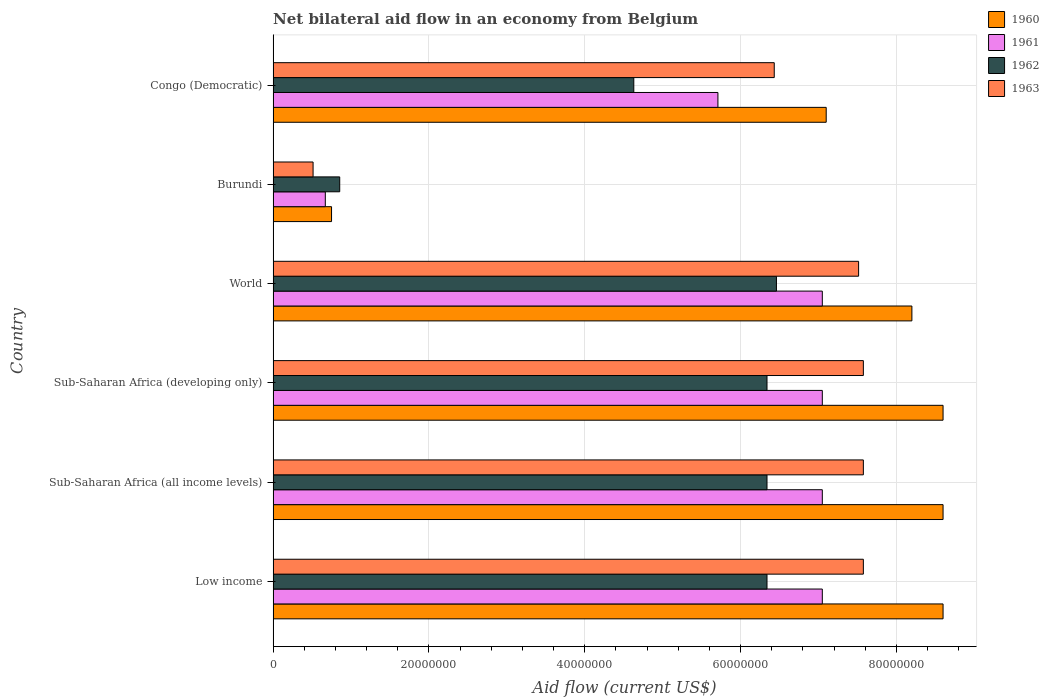Are the number of bars per tick equal to the number of legend labels?
Keep it short and to the point. Yes. What is the label of the 2nd group of bars from the top?
Keep it short and to the point. Burundi. In how many cases, is the number of bars for a given country not equal to the number of legend labels?
Offer a very short reply. 0. What is the net bilateral aid flow in 1963 in Sub-Saharan Africa (all income levels)?
Provide a short and direct response. 7.58e+07. Across all countries, what is the maximum net bilateral aid flow in 1963?
Make the answer very short. 7.58e+07. Across all countries, what is the minimum net bilateral aid flow in 1961?
Ensure brevity in your answer.  6.70e+06. In which country was the net bilateral aid flow in 1962 maximum?
Your answer should be very brief. World. In which country was the net bilateral aid flow in 1961 minimum?
Offer a terse response. Burundi. What is the total net bilateral aid flow in 1960 in the graph?
Offer a very short reply. 4.18e+08. What is the difference between the net bilateral aid flow in 1962 in Burundi and that in Sub-Saharan Africa (developing only)?
Give a very brief answer. -5.48e+07. What is the difference between the net bilateral aid flow in 1960 in Sub-Saharan Africa (all income levels) and the net bilateral aid flow in 1961 in Sub-Saharan Africa (developing only)?
Provide a short and direct response. 1.55e+07. What is the average net bilateral aid flow in 1962 per country?
Your answer should be very brief. 5.16e+07. What is the difference between the net bilateral aid flow in 1960 and net bilateral aid flow in 1961 in World?
Provide a short and direct response. 1.15e+07. In how many countries, is the net bilateral aid flow in 1961 greater than 12000000 US$?
Offer a very short reply. 5. What is the ratio of the net bilateral aid flow in 1961 in Congo (Democratic) to that in Sub-Saharan Africa (all income levels)?
Your response must be concise. 0.81. Is the net bilateral aid flow in 1961 in Low income less than that in Sub-Saharan Africa (developing only)?
Keep it short and to the point. No. What is the difference between the highest and the lowest net bilateral aid flow in 1961?
Provide a succinct answer. 6.38e+07. What does the 2nd bar from the top in World represents?
Make the answer very short. 1962. How many countries are there in the graph?
Offer a terse response. 6. What is the difference between two consecutive major ticks on the X-axis?
Your answer should be compact. 2.00e+07. Are the values on the major ticks of X-axis written in scientific E-notation?
Provide a short and direct response. No. Does the graph contain grids?
Keep it short and to the point. Yes. Where does the legend appear in the graph?
Make the answer very short. Top right. How many legend labels are there?
Provide a short and direct response. 4. What is the title of the graph?
Offer a very short reply. Net bilateral aid flow in an economy from Belgium. Does "1991" appear as one of the legend labels in the graph?
Your answer should be very brief. No. What is the label or title of the X-axis?
Ensure brevity in your answer.  Aid flow (current US$). What is the Aid flow (current US$) of 1960 in Low income?
Your answer should be very brief. 8.60e+07. What is the Aid flow (current US$) in 1961 in Low income?
Your response must be concise. 7.05e+07. What is the Aid flow (current US$) in 1962 in Low income?
Provide a succinct answer. 6.34e+07. What is the Aid flow (current US$) in 1963 in Low income?
Give a very brief answer. 7.58e+07. What is the Aid flow (current US$) of 1960 in Sub-Saharan Africa (all income levels)?
Make the answer very short. 8.60e+07. What is the Aid flow (current US$) in 1961 in Sub-Saharan Africa (all income levels)?
Ensure brevity in your answer.  7.05e+07. What is the Aid flow (current US$) in 1962 in Sub-Saharan Africa (all income levels)?
Offer a terse response. 6.34e+07. What is the Aid flow (current US$) of 1963 in Sub-Saharan Africa (all income levels)?
Keep it short and to the point. 7.58e+07. What is the Aid flow (current US$) of 1960 in Sub-Saharan Africa (developing only)?
Provide a short and direct response. 8.60e+07. What is the Aid flow (current US$) in 1961 in Sub-Saharan Africa (developing only)?
Give a very brief answer. 7.05e+07. What is the Aid flow (current US$) of 1962 in Sub-Saharan Africa (developing only)?
Your answer should be compact. 6.34e+07. What is the Aid flow (current US$) of 1963 in Sub-Saharan Africa (developing only)?
Offer a terse response. 7.58e+07. What is the Aid flow (current US$) in 1960 in World?
Provide a short and direct response. 8.20e+07. What is the Aid flow (current US$) of 1961 in World?
Ensure brevity in your answer.  7.05e+07. What is the Aid flow (current US$) of 1962 in World?
Offer a very short reply. 6.46e+07. What is the Aid flow (current US$) in 1963 in World?
Your response must be concise. 7.52e+07. What is the Aid flow (current US$) in 1960 in Burundi?
Your answer should be compact. 7.50e+06. What is the Aid flow (current US$) in 1961 in Burundi?
Offer a very short reply. 6.70e+06. What is the Aid flow (current US$) of 1962 in Burundi?
Ensure brevity in your answer.  8.55e+06. What is the Aid flow (current US$) in 1963 in Burundi?
Offer a terse response. 5.13e+06. What is the Aid flow (current US$) of 1960 in Congo (Democratic)?
Make the answer very short. 7.10e+07. What is the Aid flow (current US$) of 1961 in Congo (Democratic)?
Keep it short and to the point. 5.71e+07. What is the Aid flow (current US$) of 1962 in Congo (Democratic)?
Your answer should be very brief. 4.63e+07. What is the Aid flow (current US$) in 1963 in Congo (Democratic)?
Your response must be concise. 6.43e+07. Across all countries, what is the maximum Aid flow (current US$) in 1960?
Give a very brief answer. 8.60e+07. Across all countries, what is the maximum Aid flow (current US$) in 1961?
Provide a succinct answer. 7.05e+07. Across all countries, what is the maximum Aid flow (current US$) in 1962?
Ensure brevity in your answer.  6.46e+07. Across all countries, what is the maximum Aid flow (current US$) in 1963?
Your answer should be very brief. 7.58e+07. Across all countries, what is the minimum Aid flow (current US$) in 1960?
Your answer should be compact. 7.50e+06. Across all countries, what is the minimum Aid flow (current US$) in 1961?
Your response must be concise. 6.70e+06. Across all countries, what is the minimum Aid flow (current US$) in 1962?
Provide a succinct answer. 8.55e+06. Across all countries, what is the minimum Aid flow (current US$) of 1963?
Make the answer very short. 5.13e+06. What is the total Aid flow (current US$) in 1960 in the graph?
Provide a succinct answer. 4.18e+08. What is the total Aid flow (current US$) of 1961 in the graph?
Ensure brevity in your answer.  3.46e+08. What is the total Aid flow (current US$) of 1962 in the graph?
Offer a very short reply. 3.10e+08. What is the total Aid flow (current US$) in 1963 in the graph?
Provide a succinct answer. 3.72e+08. What is the difference between the Aid flow (current US$) in 1960 in Low income and that in Sub-Saharan Africa (all income levels)?
Give a very brief answer. 0. What is the difference between the Aid flow (current US$) of 1962 in Low income and that in Sub-Saharan Africa (all income levels)?
Offer a terse response. 0. What is the difference between the Aid flow (current US$) of 1960 in Low income and that in Sub-Saharan Africa (developing only)?
Ensure brevity in your answer.  0. What is the difference between the Aid flow (current US$) in 1961 in Low income and that in Sub-Saharan Africa (developing only)?
Your answer should be very brief. 0. What is the difference between the Aid flow (current US$) of 1962 in Low income and that in Sub-Saharan Africa (developing only)?
Give a very brief answer. 0. What is the difference between the Aid flow (current US$) of 1963 in Low income and that in Sub-Saharan Africa (developing only)?
Give a very brief answer. 0. What is the difference between the Aid flow (current US$) in 1961 in Low income and that in World?
Offer a terse response. 0. What is the difference between the Aid flow (current US$) of 1962 in Low income and that in World?
Provide a succinct answer. -1.21e+06. What is the difference between the Aid flow (current US$) of 1963 in Low income and that in World?
Your answer should be compact. 6.10e+05. What is the difference between the Aid flow (current US$) of 1960 in Low income and that in Burundi?
Keep it short and to the point. 7.85e+07. What is the difference between the Aid flow (current US$) of 1961 in Low income and that in Burundi?
Offer a terse response. 6.38e+07. What is the difference between the Aid flow (current US$) in 1962 in Low income and that in Burundi?
Your answer should be very brief. 5.48e+07. What is the difference between the Aid flow (current US$) in 1963 in Low income and that in Burundi?
Your answer should be compact. 7.06e+07. What is the difference between the Aid flow (current US$) of 1960 in Low income and that in Congo (Democratic)?
Keep it short and to the point. 1.50e+07. What is the difference between the Aid flow (current US$) in 1961 in Low income and that in Congo (Democratic)?
Ensure brevity in your answer.  1.34e+07. What is the difference between the Aid flow (current US$) of 1962 in Low income and that in Congo (Democratic)?
Your answer should be compact. 1.71e+07. What is the difference between the Aid flow (current US$) in 1963 in Low income and that in Congo (Democratic)?
Give a very brief answer. 1.14e+07. What is the difference between the Aid flow (current US$) in 1961 in Sub-Saharan Africa (all income levels) and that in Sub-Saharan Africa (developing only)?
Provide a short and direct response. 0. What is the difference between the Aid flow (current US$) of 1962 in Sub-Saharan Africa (all income levels) and that in Sub-Saharan Africa (developing only)?
Your answer should be very brief. 0. What is the difference between the Aid flow (current US$) in 1963 in Sub-Saharan Africa (all income levels) and that in Sub-Saharan Africa (developing only)?
Offer a terse response. 0. What is the difference between the Aid flow (current US$) of 1960 in Sub-Saharan Africa (all income levels) and that in World?
Make the answer very short. 4.00e+06. What is the difference between the Aid flow (current US$) in 1962 in Sub-Saharan Africa (all income levels) and that in World?
Offer a very short reply. -1.21e+06. What is the difference between the Aid flow (current US$) of 1963 in Sub-Saharan Africa (all income levels) and that in World?
Make the answer very short. 6.10e+05. What is the difference between the Aid flow (current US$) in 1960 in Sub-Saharan Africa (all income levels) and that in Burundi?
Offer a very short reply. 7.85e+07. What is the difference between the Aid flow (current US$) in 1961 in Sub-Saharan Africa (all income levels) and that in Burundi?
Ensure brevity in your answer.  6.38e+07. What is the difference between the Aid flow (current US$) of 1962 in Sub-Saharan Africa (all income levels) and that in Burundi?
Provide a succinct answer. 5.48e+07. What is the difference between the Aid flow (current US$) of 1963 in Sub-Saharan Africa (all income levels) and that in Burundi?
Your answer should be very brief. 7.06e+07. What is the difference between the Aid flow (current US$) of 1960 in Sub-Saharan Africa (all income levels) and that in Congo (Democratic)?
Keep it short and to the point. 1.50e+07. What is the difference between the Aid flow (current US$) of 1961 in Sub-Saharan Africa (all income levels) and that in Congo (Democratic)?
Your answer should be compact. 1.34e+07. What is the difference between the Aid flow (current US$) of 1962 in Sub-Saharan Africa (all income levels) and that in Congo (Democratic)?
Your answer should be compact. 1.71e+07. What is the difference between the Aid flow (current US$) in 1963 in Sub-Saharan Africa (all income levels) and that in Congo (Democratic)?
Give a very brief answer. 1.14e+07. What is the difference between the Aid flow (current US$) of 1960 in Sub-Saharan Africa (developing only) and that in World?
Give a very brief answer. 4.00e+06. What is the difference between the Aid flow (current US$) of 1961 in Sub-Saharan Africa (developing only) and that in World?
Offer a very short reply. 0. What is the difference between the Aid flow (current US$) in 1962 in Sub-Saharan Africa (developing only) and that in World?
Your response must be concise. -1.21e+06. What is the difference between the Aid flow (current US$) in 1963 in Sub-Saharan Africa (developing only) and that in World?
Ensure brevity in your answer.  6.10e+05. What is the difference between the Aid flow (current US$) of 1960 in Sub-Saharan Africa (developing only) and that in Burundi?
Your answer should be compact. 7.85e+07. What is the difference between the Aid flow (current US$) in 1961 in Sub-Saharan Africa (developing only) and that in Burundi?
Offer a very short reply. 6.38e+07. What is the difference between the Aid flow (current US$) in 1962 in Sub-Saharan Africa (developing only) and that in Burundi?
Your response must be concise. 5.48e+07. What is the difference between the Aid flow (current US$) in 1963 in Sub-Saharan Africa (developing only) and that in Burundi?
Ensure brevity in your answer.  7.06e+07. What is the difference between the Aid flow (current US$) of 1960 in Sub-Saharan Africa (developing only) and that in Congo (Democratic)?
Your answer should be very brief. 1.50e+07. What is the difference between the Aid flow (current US$) of 1961 in Sub-Saharan Africa (developing only) and that in Congo (Democratic)?
Provide a short and direct response. 1.34e+07. What is the difference between the Aid flow (current US$) in 1962 in Sub-Saharan Africa (developing only) and that in Congo (Democratic)?
Offer a terse response. 1.71e+07. What is the difference between the Aid flow (current US$) in 1963 in Sub-Saharan Africa (developing only) and that in Congo (Democratic)?
Keep it short and to the point. 1.14e+07. What is the difference between the Aid flow (current US$) in 1960 in World and that in Burundi?
Your answer should be very brief. 7.45e+07. What is the difference between the Aid flow (current US$) in 1961 in World and that in Burundi?
Offer a very short reply. 6.38e+07. What is the difference between the Aid flow (current US$) of 1962 in World and that in Burundi?
Keep it short and to the point. 5.61e+07. What is the difference between the Aid flow (current US$) of 1963 in World and that in Burundi?
Make the answer very short. 7.00e+07. What is the difference between the Aid flow (current US$) in 1960 in World and that in Congo (Democratic)?
Provide a short and direct response. 1.10e+07. What is the difference between the Aid flow (current US$) of 1961 in World and that in Congo (Democratic)?
Keep it short and to the point. 1.34e+07. What is the difference between the Aid flow (current US$) in 1962 in World and that in Congo (Democratic)?
Offer a very short reply. 1.83e+07. What is the difference between the Aid flow (current US$) in 1963 in World and that in Congo (Democratic)?
Your answer should be compact. 1.08e+07. What is the difference between the Aid flow (current US$) of 1960 in Burundi and that in Congo (Democratic)?
Offer a terse response. -6.35e+07. What is the difference between the Aid flow (current US$) in 1961 in Burundi and that in Congo (Democratic)?
Ensure brevity in your answer.  -5.04e+07. What is the difference between the Aid flow (current US$) in 1962 in Burundi and that in Congo (Democratic)?
Make the answer very short. -3.78e+07. What is the difference between the Aid flow (current US$) in 1963 in Burundi and that in Congo (Democratic)?
Your answer should be compact. -5.92e+07. What is the difference between the Aid flow (current US$) in 1960 in Low income and the Aid flow (current US$) in 1961 in Sub-Saharan Africa (all income levels)?
Your response must be concise. 1.55e+07. What is the difference between the Aid flow (current US$) in 1960 in Low income and the Aid flow (current US$) in 1962 in Sub-Saharan Africa (all income levels)?
Your response must be concise. 2.26e+07. What is the difference between the Aid flow (current US$) in 1960 in Low income and the Aid flow (current US$) in 1963 in Sub-Saharan Africa (all income levels)?
Offer a very short reply. 1.02e+07. What is the difference between the Aid flow (current US$) of 1961 in Low income and the Aid flow (current US$) of 1962 in Sub-Saharan Africa (all income levels)?
Provide a short and direct response. 7.10e+06. What is the difference between the Aid flow (current US$) in 1961 in Low income and the Aid flow (current US$) in 1963 in Sub-Saharan Africa (all income levels)?
Ensure brevity in your answer.  -5.27e+06. What is the difference between the Aid flow (current US$) of 1962 in Low income and the Aid flow (current US$) of 1963 in Sub-Saharan Africa (all income levels)?
Your response must be concise. -1.24e+07. What is the difference between the Aid flow (current US$) in 1960 in Low income and the Aid flow (current US$) in 1961 in Sub-Saharan Africa (developing only)?
Offer a terse response. 1.55e+07. What is the difference between the Aid flow (current US$) in 1960 in Low income and the Aid flow (current US$) in 1962 in Sub-Saharan Africa (developing only)?
Keep it short and to the point. 2.26e+07. What is the difference between the Aid flow (current US$) in 1960 in Low income and the Aid flow (current US$) in 1963 in Sub-Saharan Africa (developing only)?
Provide a succinct answer. 1.02e+07. What is the difference between the Aid flow (current US$) of 1961 in Low income and the Aid flow (current US$) of 1962 in Sub-Saharan Africa (developing only)?
Provide a short and direct response. 7.10e+06. What is the difference between the Aid flow (current US$) of 1961 in Low income and the Aid flow (current US$) of 1963 in Sub-Saharan Africa (developing only)?
Keep it short and to the point. -5.27e+06. What is the difference between the Aid flow (current US$) in 1962 in Low income and the Aid flow (current US$) in 1963 in Sub-Saharan Africa (developing only)?
Your answer should be very brief. -1.24e+07. What is the difference between the Aid flow (current US$) of 1960 in Low income and the Aid flow (current US$) of 1961 in World?
Your response must be concise. 1.55e+07. What is the difference between the Aid flow (current US$) of 1960 in Low income and the Aid flow (current US$) of 1962 in World?
Provide a short and direct response. 2.14e+07. What is the difference between the Aid flow (current US$) of 1960 in Low income and the Aid flow (current US$) of 1963 in World?
Offer a terse response. 1.08e+07. What is the difference between the Aid flow (current US$) of 1961 in Low income and the Aid flow (current US$) of 1962 in World?
Provide a succinct answer. 5.89e+06. What is the difference between the Aid flow (current US$) in 1961 in Low income and the Aid flow (current US$) in 1963 in World?
Offer a terse response. -4.66e+06. What is the difference between the Aid flow (current US$) in 1962 in Low income and the Aid flow (current US$) in 1963 in World?
Give a very brief answer. -1.18e+07. What is the difference between the Aid flow (current US$) in 1960 in Low income and the Aid flow (current US$) in 1961 in Burundi?
Your answer should be compact. 7.93e+07. What is the difference between the Aid flow (current US$) in 1960 in Low income and the Aid flow (current US$) in 1962 in Burundi?
Make the answer very short. 7.74e+07. What is the difference between the Aid flow (current US$) of 1960 in Low income and the Aid flow (current US$) of 1963 in Burundi?
Provide a succinct answer. 8.09e+07. What is the difference between the Aid flow (current US$) in 1961 in Low income and the Aid flow (current US$) in 1962 in Burundi?
Your answer should be very brief. 6.20e+07. What is the difference between the Aid flow (current US$) in 1961 in Low income and the Aid flow (current US$) in 1963 in Burundi?
Provide a short and direct response. 6.54e+07. What is the difference between the Aid flow (current US$) in 1962 in Low income and the Aid flow (current US$) in 1963 in Burundi?
Your answer should be very brief. 5.83e+07. What is the difference between the Aid flow (current US$) of 1960 in Low income and the Aid flow (current US$) of 1961 in Congo (Democratic)?
Provide a succinct answer. 2.89e+07. What is the difference between the Aid flow (current US$) in 1960 in Low income and the Aid flow (current US$) in 1962 in Congo (Democratic)?
Provide a succinct answer. 3.97e+07. What is the difference between the Aid flow (current US$) in 1960 in Low income and the Aid flow (current US$) in 1963 in Congo (Democratic)?
Offer a very short reply. 2.17e+07. What is the difference between the Aid flow (current US$) in 1961 in Low income and the Aid flow (current US$) in 1962 in Congo (Democratic)?
Your response must be concise. 2.42e+07. What is the difference between the Aid flow (current US$) in 1961 in Low income and the Aid flow (current US$) in 1963 in Congo (Democratic)?
Your response must be concise. 6.17e+06. What is the difference between the Aid flow (current US$) of 1962 in Low income and the Aid flow (current US$) of 1963 in Congo (Democratic)?
Offer a very short reply. -9.30e+05. What is the difference between the Aid flow (current US$) in 1960 in Sub-Saharan Africa (all income levels) and the Aid flow (current US$) in 1961 in Sub-Saharan Africa (developing only)?
Offer a very short reply. 1.55e+07. What is the difference between the Aid flow (current US$) in 1960 in Sub-Saharan Africa (all income levels) and the Aid flow (current US$) in 1962 in Sub-Saharan Africa (developing only)?
Offer a very short reply. 2.26e+07. What is the difference between the Aid flow (current US$) in 1960 in Sub-Saharan Africa (all income levels) and the Aid flow (current US$) in 1963 in Sub-Saharan Africa (developing only)?
Offer a very short reply. 1.02e+07. What is the difference between the Aid flow (current US$) in 1961 in Sub-Saharan Africa (all income levels) and the Aid flow (current US$) in 1962 in Sub-Saharan Africa (developing only)?
Provide a succinct answer. 7.10e+06. What is the difference between the Aid flow (current US$) in 1961 in Sub-Saharan Africa (all income levels) and the Aid flow (current US$) in 1963 in Sub-Saharan Africa (developing only)?
Keep it short and to the point. -5.27e+06. What is the difference between the Aid flow (current US$) in 1962 in Sub-Saharan Africa (all income levels) and the Aid flow (current US$) in 1963 in Sub-Saharan Africa (developing only)?
Offer a very short reply. -1.24e+07. What is the difference between the Aid flow (current US$) in 1960 in Sub-Saharan Africa (all income levels) and the Aid flow (current US$) in 1961 in World?
Keep it short and to the point. 1.55e+07. What is the difference between the Aid flow (current US$) in 1960 in Sub-Saharan Africa (all income levels) and the Aid flow (current US$) in 1962 in World?
Your answer should be very brief. 2.14e+07. What is the difference between the Aid flow (current US$) in 1960 in Sub-Saharan Africa (all income levels) and the Aid flow (current US$) in 1963 in World?
Keep it short and to the point. 1.08e+07. What is the difference between the Aid flow (current US$) of 1961 in Sub-Saharan Africa (all income levels) and the Aid flow (current US$) of 1962 in World?
Your answer should be compact. 5.89e+06. What is the difference between the Aid flow (current US$) of 1961 in Sub-Saharan Africa (all income levels) and the Aid flow (current US$) of 1963 in World?
Ensure brevity in your answer.  -4.66e+06. What is the difference between the Aid flow (current US$) of 1962 in Sub-Saharan Africa (all income levels) and the Aid flow (current US$) of 1963 in World?
Your response must be concise. -1.18e+07. What is the difference between the Aid flow (current US$) in 1960 in Sub-Saharan Africa (all income levels) and the Aid flow (current US$) in 1961 in Burundi?
Your answer should be very brief. 7.93e+07. What is the difference between the Aid flow (current US$) of 1960 in Sub-Saharan Africa (all income levels) and the Aid flow (current US$) of 1962 in Burundi?
Your answer should be very brief. 7.74e+07. What is the difference between the Aid flow (current US$) in 1960 in Sub-Saharan Africa (all income levels) and the Aid flow (current US$) in 1963 in Burundi?
Offer a very short reply. 8.09e+07. What is the difference between the Aid flow (current US$) in 1961 in Sub-Saharan Africa (all income levels) and the Aid flow (current US$) in 1962 in Burundi?
Give a very brief answer. 6.20e+07. What is the difference between the Aid flow (current US$) of 1961 in Sub-Saharan Africa (all income levels) and the Aid flow (current US$) of 1963 in Burundi?
Your answer should be very brief. 6.54e+07. What is the difference between the Aid flow (current US$) of 1962 in Sub-Saharan Africa (all income levels) and the Aid flow (current US$) of 1963 in Burundi?
Offer a very short reply. 5.83e+07. What is the difference between the Aid flow (current US$) in 1960 in Sub-Saharan Africa (all income levels) and the Aid flow (current US$) in 1961 in Congo (Democratic)?
Make the answer very short. 2.89e+07. What is the difference between the Aid flow (current US$) in 1960 in Sub-Saharan Africa (all income levels) and the Aid flow (current US$) in 1962 in Congo (Democratic)?
Keep it short and to the point. 3.97e+07. What is the difference between the Aid flow (current US$) of 1960 in Sub-Saharan Africa (all income levels) and the Aid flow (current US$) of 1963 in Congo (Democratic)?
Provide a short and direct response. 2.17e+07. What is the difference between the Aid flow (current US$) in 1961 in Sub-Saharan Africa (all income levels) and the Aid flow (current US$) in 1962 in Congo (Democratic)?
Give a very brief answer. 2.42e+07. What is the difference between the Aid flow (current US$) in 1961 in Sub-Saharan Africa (all income levels) and the Aid flow (current US$) in 1963 in Congo (Democratic)?
Ensure brevity in your answer.  6.17e+06. What is the difference between the Aid flow (current US$) of 1962 in Sub-Saharan Africa (all income levels) and the Aid flow (current US$) of 1963 in Congo (Democratic)?
Ensure brevity in your answer.  -9.30e+05. What is the difference between the Aid flow (current US$) of 1960 in Sub-Saharan Africa (developing only) and the Aid flow (current US$) of 1961 in World?
Provide a short and direct response. 1.55e+07. What is the difference between the Aid flow (current US$) in 1960 in Sub-Saharan Africa (developing only) and the Aid flow (current US$) in 1962 in World?
Your answer should be compact. 2.14e+07. What is the difference between the Aid flow (current US$) in 1960 in Sub-Saharan Africa (developing only) and the Aid flow (current US$) in 1963 in World?
Provide a short and direct response. 1.08e+07. What is the difference between the Aid flow (current US$) in 1961 in Sub-Saharan Africa (developing only) and the Aid flow (current US$) in 1962 in World?
Offer a very short reply. 5.89e+06. What is the difference between the Aid flow (current US$) in 1961 in Sub-Saharan Africa (developing only) and the Aid flow (current US$) in 1963 in World?
Your answer should be compact. -4.66e+06. What is the difference between the Aid flow (current US$) in 1962 in Sub-Saharan Africa (developing only) and the Aid flow (current US$) in 1963 in World?
Your response must be concise. -1.18e+07. What is the difference between the Aid flow (current US$) of 1960 in Sub-Saharan Africa (developing only) and the Aid flow (current US$) of 1961 in Burundi?
Provide a succinct answer. 7.93e+07. What is the difference between the Aid flow (current US$) of 1960 in Sub-Saharan Africa (developing only) and the Aid flow (current US$) of 1962 in Burundi?
Offer a very short reply. 7.74e+07. What is the difference between the Aid flow (current US$) of 1960 in Sub-Saharan Africa (developing only) and the Aid flow (current US$) of 1963 in Burundi?
Offer a terse response. 8.09e+07. What is the difference between the Aid flow (current US$) of 1961 in Sub-Saharan Africa (developing only) and the Aid flow (current US$) of 1962 in Burundi?
Your answer should be very brief. 6.20e+07. What is the difference between the Aid flow (current US$) in 1961 in Sub-Saharan Africa (developing only) and the Aid flow (current US$) in 1963 in Burundi?
Give a very brief answer. 6.54e+07. What is the difference between the Aid flow (current US$) of 1962 in Sub-Saharan Africa (developing only) and the Aid flow (current US$) of 1963 in Burundi?
Your answer should be compact. 5.83e+07. What is the difference between the Aid flow (current US$) in 1960 in Sub-Saharan Africa (developing only) and the Aid flow (current US$) in 1961 in Congo (Democratic)?
Provide a succinct answer. 2.89e+07. What is the difference between the Aid flow (current US$) of 1960 in Sub-Saharan Africa (developing only) and the Aid flow (current US$) of 1962 in Congo (Democratic)?
Your response must be concise. 3.97e+07. What is the difference between the Aid flow (current US$) of 1960 in Sub-Saharan Africa (developing only) and the Aid flow (current US$) of 1963 in Congo (Democratic)?
Provide a short and direct response. 2.17e+07. What is the difference between the Aid flow (current US$) of 1961 in Sub-Saharan Africa (developing only) and the Aid flow (current US$) of 1962 in Congo (Democratic)?
Keep it short and to the point. 2.42e+07. What is the difference between the Aid flow (current US$) in 1961 in Sub-Saharan Africa (developing only) and the Aid flow (current US$) in 1963 in Congo (Democratic)?
Keep it short and to the point. 6.17e+06. What is the difference between the Aid flow (current US$) in 1962 in Sub-Saharan Africa (developing only) and the Aid flow (current US$) in 1963 in Congo (Democratic)?
Your answer should be compact. -9.30e+05. What is the difference between the Aid flow (current US$) in 1960 in World and the Aid flow (current US$) in 1961 in Burundi?
Ensure brevity in your answer.  7.53e+07. What is the difference between the Aid flow (current US$) in 1960 in World and the Aid flow (current US$) in 1962 in Burundi?
Make the answer very short. 7.34e+07. What is the difference between the Aid flow (current US$) in 1960 in World and the Aid flow (current US$) in 1963 in Burundi?
Give a very brief answer. 7.69e+07. What is the difference between the Aid flow (current US$) in 1961 in World and the Aid flow (current US$) in 1962 in Burundi?
Offer a terse response. 6.20e+07. What is the difference between the Aid flow (current US$) in 1961 in World and the Aid flow (current US$) in 1963 in Burundi?
Give a very brief answer. 6.54e+07. What is the difference between the Aid flow (current US$) in 1962 in World and the Aid flow (current US$) in 1963 in Burundi?
Your response must be concise. 5.95e+07. What is the difference between the Aid flow (current US$) of 1960 in World and the Aid flow (current US$) of 1961 in Congo (Democratic)?
Offer a very short reply. 2.49e+07. What is the difference between the Aid flow (current US$) in 1960 in World and the Aid flow (current US$) in 1962 in Congo (Democratic)?
Give a very brief answer. 3.57e+07. What is the difference between the Aid flow (current US$) in 1960 in World and the Aid flow (current US$) in 1963 in Congo (Democratic)?
Offer a terse response. 1.77e+07. What is the difference between the Aid flow (current US$) of 1961 in World and the Aid flow (current US$) of 1962 in Congo (Democratic)?
Give a very brief answer. 2.42e+07. What is the difference between the Aid flow (current US$) of 1961 in World and the Aid flow (current US$) of 1963 in Congo (Democratic)?
Provide a succinct answer. 6.17e+06. What is the difference between the Aid flow (current US$) in 1962 in World and the Aid flow (current US$) in 1963 in Congo (Democratic)?
Your response must be concise. 2.80e+05. What is the difference between the Aid flow (current US$) in 1960 in Burundi and the Aid flow (current US$) in 1961 in Congo (Democratic)?
Keep it short and to the point. -4.96e+07. What is the difference between the Aid flow (current US$) of 1960 in Burundi and the Aid flow (current US$) of 1962 in Congo (Democratic)?
Your answer should be compact. -3.88e+07. What is the difference between the Aid flow (current US$) in 1960 in Burundi and the Aid flow (current US$) in 1963 in Congo (Democratic)?
Make the answer very short. -5.68e+07. What is the difference between the Aid flow (current US$) of 1961 in Burundi and the Aid flow (current US$) of 1962 in Congo (Democratic)?
Offer a very short reply. -3.96e+07. What is the difference between the Aid flow (current US$) in 1961 in Burundi and the Aid flow (current US$) in 1963 in Congo (Democratic)?
Offer a very short reply. -5.76e+07. What is the difference between the Aid flow (current US$) in 1962 in Burundi and the Aid flow (current US$) in 1963 in Congo (Democratic)?
Make the answer very short. -5.58e+07. What is the average Aid flow (current US$) in 1960 per country?
Offer a terse response. 6.98e+07. What is the average Aid flow (current US$) of 1961 per country?
Give a very brief answer. 5.76e+07. What is the average Aid flow (current US$) in 1962 per country?
Offer a terse response. 5.16e+07. What is the average Aid flow (current US$) of 1963 per country?
Offer a terse response. 6.20e+07. What is the difference between the Aid flow (current US$) in 1960 and Aid flow (current US$) in 1961 in Low income?
Keep it short and to the point. 1.55e+07. What is the difference between the Aid flow (current US$) of 1960 and Aid flow (current US$) of 1962 in Low income?
Your answer should be compact. 2.26e+07. What is the difference between the Aid flow (current US$) of 1960 and Aid flow (current US$) of 1963 in Low income?
Make the answer very short. 1.02e+07. What is the difference between the Aid flow (current US$) in 1961 and Aid flow (current US$) in 1962 in Low income?
Your answer should be compact. 7.10e+06. What is the difference between the Aid flow (current US$) in 1961 and Aid flow (current US$) in 1963 in Low income?
Provide a succinct answer. -5.27e+06. What is the difference between the Aid flow (current US$) of 1962 and Aid flow (current US$) of 1963 in Low income?
Keep it short and to the point. -1.24e+07. What is the difference between the Aid flow (current US$) in 1960 and Aid flow (current US$) in 1961 in Sub-Saharan Africa (all income levels)?
Provide a succinct answer. 1.55e+07. What is the difference between the Aid flow (current US$) in 1960 and Aid flow (current US$) in 1962 in Sub-Saharan Africa (all income levels)?
Keep it short and to the point. 2.26e+07. What is the difference between the Aid flow (current US$) of 1960 and Aid flow (current US$) of 1963 in Sub-Saharan Africa (all income levels)?
Your answer should be very brief. 1.02e+07. What is the difference between the Aid flow (current US$) of 1961 and Aid flow (current US$) of 1962 in Sub-Saharan Africa (all income levels)?
Provide a short and direct response. 7.10e+06. What is the difference between the Aid flow (current US$) of 1961 and Aid flow (current US$) of 1963 in Sub-Saharan Africa (all income levels)?
Provide a succinct answer. -5.27e+06. What is the difference between the Aid flow (current US$) in 1962 and Aid flow (current US$) in 1963 in Sub-Saharan Africa (all income levels)?
Your response must be concise. -1.24e+07. What is the difference between the Aid flow (current US$) in 1960 and Aid flow (current US$) in 1961 in Sub-Saharan Africa (developing only)?
Offer a very short reply. 1.55e+07. What is the difference between the Aid flow (current US$) of 1960 and Aid flow (current US$) of 1962 in Sub-Saharan Africa (developing only)?
Keep it short and to the point. 2.26e+07. What is the difference between the Aid flow (current US$) of 1960 and Aid flow (current US$) of 1963 in Sub-Saharan Africa (developing only)?
Provide a short and direct response. 1.02e+07. What is the difference between the Aid flow (current US$) in 1961 and Aid flow (current US$) in 1962 in Sub-Saharan Africa (developing only)?
Offer a terse response. 7.10e+06. What is the difference between the Aid flow (current US$) in 1961 and Aid flow (current US$) in 1963 in Sub-Saharan Africa (developing only)?
Keep it short and to the point. -5.27e+06. What is the difference between the Aid flow (current US$) of 1962 and Aid flow (current US$) of 1963 in Sub-Saharan Africa (developing only)?
Your answer should be compact. -1.24e+07. What is the difference between the Aid flow (current US$) of 1960 and Aid flow (current US$) of 1961 in World?
Ensure brevity in your answer.  1.15e+07. What is the difference between the Aid flow (current US$) in 1960 and Aid flow (current US$) in 1962 in World?
Offer a very short reply. 1.74e+07. What is the difference between the Aid flow (current US$) in 1960 and Aid flow (current US$) in 1963 in World?
Offer a very short reply. 6.84e+06. What is the difference between the Aid flow (current US$) of 1961 and Aid flow (current US$) of 1962 in World?
Your answer should be compact. 5.89e+06. What is the difference between the Aid flow (current US$) in 1961 and Aid flow (current US$) in 1963 in World?
Keep it short and to the point. -4.66e+06. What is the difference between the Aid flow (current US$) of 1962 and Aid flow (current US$) of 1963 in World?
Offer a terse response. -1.06e+07. What is the difference between the Aid flow (current US$) in 1960 and Aid flow (current US$) in 1962 in Burundi?
Provide a short and direct response. -1.05e+06. What is the difference between the Aid flow (current US$) in 1960 and Aid flow (current US$) in 1963 in Burundi?
Keep it short and to the point. 2.37e+06. What is the difference between the Aid flow (current US$) in 1961 and Aid flow (current US$) in 1962 in Burundi?
Keep it short and to the point. -1.85e+06. What is the difference between the Aid flow (current US$) in 1961 and Aid flow (current US$) in 1963 in Burundi?
Provide a short and direct response. 1.57e+06. What is the difference between the Aid flow (current US$) in 1962 and Aid flow (current US$) in 1963 in Burundi?
Provide a short and direct response. 3.42e+06. What is the difference between the Aid flow (current US$) in 1960 and Aid flow (current US$) in 1961 in Congo (Democratic)?
Offer a terse response. 1.39e+07. What is the difference between the Aid flow (current US$) in 1960 and Aid flow (current US$) in 1962 in Congo (Democratic)?
Offer a terse response. 2.47e+07. What is the difference between the Aid flow (current US$) of 1960 and Aid flow (current US$) of 1963 in Congo (Democratic)?
Your answer should be very brief. 6.67e+06. What is the difference between the Aid flow (current US$) in 1961 and Aid flow (current US$) in 1962 in Congo (Democratic)?
Your answer should be very brief. 1.08e+07. What is the difference between the Aid flow (current US$) of 1961 and Aid flow (current US$) of 1963 in Congo (Democratic)?
Provide a succinct answer. -7.23e+06. What is the difference between the Aid flow (current US$) in 1962 and Aid flow (current US$) in 1963 in Congo (Democratic)?
Keep it short and to the point. -1.80e+07. What is the ratio of the Aid flow (current US$) of 1961 in Low income to that in Sub-Saharan Africa (all income levels)?
Provide a short and direct response. 1. What is the ratio of the Aid flow (current US$) of 1963 in Low income to that in Sub-Saharan Africa (all income levels)?
Make the answer very short. 1. What is the ratio of the Aid flow (current US$) of 1960 in Low income to that in Sub-Saharan Africa (developing only)?
Make the answer very short. 1. What is the ratio of the Aid flow (current US$) of 1961 in Low income to that in Sub-Saharan Africa (developing only)?
Ensure brevity in your answer.  1. What is the ratio of the Aid flow (current US$) in 1962 in Low income to that in Sub-Saharan Africa (developing only)?
Your response must be concise. 1. What is the ratio of the Aid flow (current US$) in 1960 in Low income to that in World?
Your answer should be compact. 1.05. What is the ratio of the Aid flow (current US$) in 1962 in Low income to that in World?
Your response must be concise. 0.98. What is the ratio of the Aid flow (current US$) of 1960 in Low income to that in Burundi?
Keep it short and to the point. 11.47. What is the ratio of the Aid flow (current US$) of 1961 in Low income to that in Burundi?
Your answer should be very brief. 10.52. What is the ratio of the Aid flow (current US$) in 1962 in Low income to that in Burundi?
Make the answer very short. 7.42. What is the ratio of the Aid flow (current US$) in 1963 in Low income to that in Burundi?
Ensure brevity in your answer.  14.77. What is the ratio of the Aid flow (current US$) of 1960 in Low income to that in Congo (Democratic)?
Provide a succinct answer. 1.21. What is the ratio of the Aid flow (current US$) of 1961 in Low income to that in Congo (Democratic)?
Make the answer very short. 1.23. What is the ratio of the Aid flow (current US$) of 1962 in Low income to that in Congo (Democratic)?
Provide a short and direct response. 1.37. What is the ratio of the Aid flow (current US$) in 1963 in Low income to that in Congo (Democratic)?
Provide a short and direct response. 1.18. What is the ratio of the Aid flow (current US$) in 1963 in Sub-Saharan Africa (all income levels) to that in Sub-Saharan Africa (developing only)?
Give a very brief answer. 1. What is the ratio of the Aid flow (current US$) of 1960 in Sub-Saharan Africa (all income levels) to that in World?
Provide a succinct answer. 1.05. What is the ratio of the Aid flow (current US$) in 1961 in Sub-Saharan Africa (all income levels) to that in World?
Your answer should be very brief. 1. What is the ratio of the Aid flow (current US$) in 1962 in Sub-Saharan Africa (all income levels) to that in World?
Your answer should be very brief. 0.98. What is the ratio of the Aid flow (current US$) in 1960 in Sub-Saharan Africa (all income levels) to that in Burundi?
Keep it short and to the point. 11.47. What is the ratio of the Aid flow (current US$) of 1961 in Sub-Saharan Africa (all income levels) to that in Burundi?
Ensure brevity in your answer.  10.52. What is the ratio of the Aid flow (current US$) of 1962 in Sub-Saharan Africa (all income levels) to that in Burundi?
Offer a terse response. 7.42. What is the ratio of the Aid flow (current US$) in 1963 in Sub-Saharan Africa (all income levels) to that in Burundi?
Offer a very short reply. 14.77. What is the ratio of the Aid flow (current US$) in 1960 in Sub-Saharan Africa (all income levels) to that in Congo (Democratic)?
Offer a terse response. 1.21. What is the ratio of the Aid flow (current US$) in 1961 in Sub-Saharan Africa (all income levels) to that in Congo (Democratic)?
Offer a terse response. 1.23. What is the ratio of the Aid flow (current US$) in 1962 in Sub-Saharan Africa (all income levels) to that in Congo (Democratic)?
Give a very brief answer. 1.37. What is the ratio of the Aid flow (current US$) of 1963 in Sub-Saharan Africa (all income levels) to that in Congo (Democratic)?
Provide a succinct answer. 1.18. What is the ratio of the Aid flow (current US$) in 1960 in Sub-Saharan Africa (developing only) to that in World?
Provide a short and direct response. 1.05. What is the ratio of the Aid flow (current US$) in 1962 in Sub-Saharan Africa (developing only) to that in World?
Give a very brief answer. 0.98. What is the ratio of the Aid flow (current US$) in 1963 in Sub-Saharan Africa (developing only) to that in World?
Your answer should be compact. 1.01. What is the ratio of the Aid flow (current US$) of 1960 in Sub-Saharan Africa (developing only) to that in Burundi?
Provide a succinct answer. 11.47. What is the ratio of the Aid flow (current US$) in 1961 in Sub-Saharan Africa (developing only) to that in Burundi?
Offer a terse response. 10.52. What is the ratio of the Aid flow (current US$) of 1962 in Sub-Saharan Africa (developing only) to that in Burundi?
Ensure brevity in your answer.  7.42. What is the ratio of the Aid flow (current US$) in 1963 in Sub-Saharan Africa (developing only) to that in Burundi?
Your response must be concise. 14.77. What is the ratio of the Aid flow (current US$) of 1960 in Sub-Saharan Africa (developing only) to that in Congo (Democratic)?
Ensure brevity in your answer.  1.21. What is the ratio of the Aid flow (current US$) of 1961 in Sub-Saharan Africa (developing only) to that in Congo (Democratic)?
Keep it short and to the point. 1.23. What is the ratio of the Aid flow (current US$) of 1962 in Sub-Saharan Africa (developing only) to that in Congo (Democratic)?
Ensure brevity in your answer.  1.37. What is the ratio of the Aid flow (current US$) in 1963 in Sub-Saharan Africa (developing only) to that in Congo (Democratic)?
Provide a short and direct response. 1.18. What is the ratio of the Aid flow (current US$) in 1960 in World to that in Burundi?
Ensure brevity in your answer.  10.93. What is the ratio of the Aid flow (current US$) of 1961 in World to that in Burundi?
Ensure brevity in your answer.  10.52. What is the ratio of the Aid flow (current US$) of 1962 in World to that in Burundi?
Ensure brevity in your answer.  7.56. What is the ratio of the Aid flow (current US$) in 1963 in World to that in Burundi?
Offer a terse response. 14.65. What is the ratio of the Aid flow (current US$) in 1960 in World to that in Congo (Democratic)?
Ensure brevity in your answer.  1.15. What is the ratio of the Aid flow (current US$) of 1961 in World to that in Congo (Democratic)?
Provide a succinct answer. 1.23. What is the ratio of the Aid flow (current US$) of 1962 in World to that in Congo (Democratic)?
Keep it short and to the point. 1.4. What is the ratio of the Aid flow (current US$) in 1963 in World to that in Congo (Democratic)?
Provide a succinct answer. 1.17. What is the ratio of the Aid flow (current US$) of 1960 in Burundi to that in Congo (Democratic)?
Give a very brief answer. 0.11. What is the ratio of the Aid flow (current US$) of 1961 in Burundi to that in Congo (Democratic)?
Your response must be concise. 0.12. What is the ratio of the Aid flow (current US$) in 1962 in Burundi to that in Congo (Democratic)?
Your response must be concise. 0.18. What is the ratio of the Aid flow (current US$) in 1963 in Burundi to that in Congo (Democratic)?
Your answer should be very brief. 0.08. What is the difference between the highest and the second highest Aid flow (current US$) in 1962?
Keep it short and to the point. 1.21e+06. What is the difference between the highest and the second highest Aid flow (current US$) in 1963?
Provide a short and direct response. 0. What is the difference between the highest and the lowest Aid flow (current US$) in 1960?
Provide a succinct answer. 7.85e+07. What is the difference between the highest and the lowest Aid flow (current US$) in 1961?
Give a very brief answer. 6.38e+07. What is the difference between the highest and the lowest Aid flow (current US$) in 1962?
Offer a terse response. 5.61e+07. What is the difference between the highest and the lowest Aid flow (current US$) in 1963?
Offer a very short reply. 7.06e+07. 